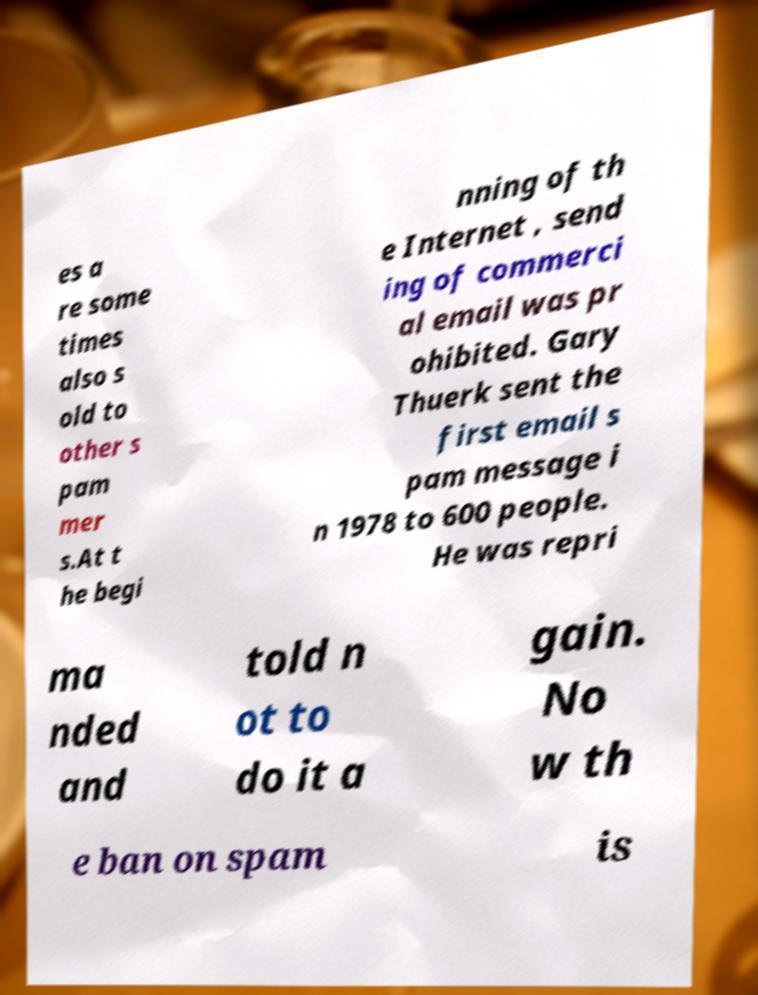Can you read and provide the text displayed in the image?This photo seems to have some interesting text. Can you extract and type it out for me? es a re some times also s old to other s pam mer s.At t he begi nning of th e Internet , send ing of commerci al email was pr ohibited. Gary Thuerk sent the first email s pam message i n 1978 to 600 people. He was repri ma nded and told n ot to do it a gain. No w th e ban on spam is 